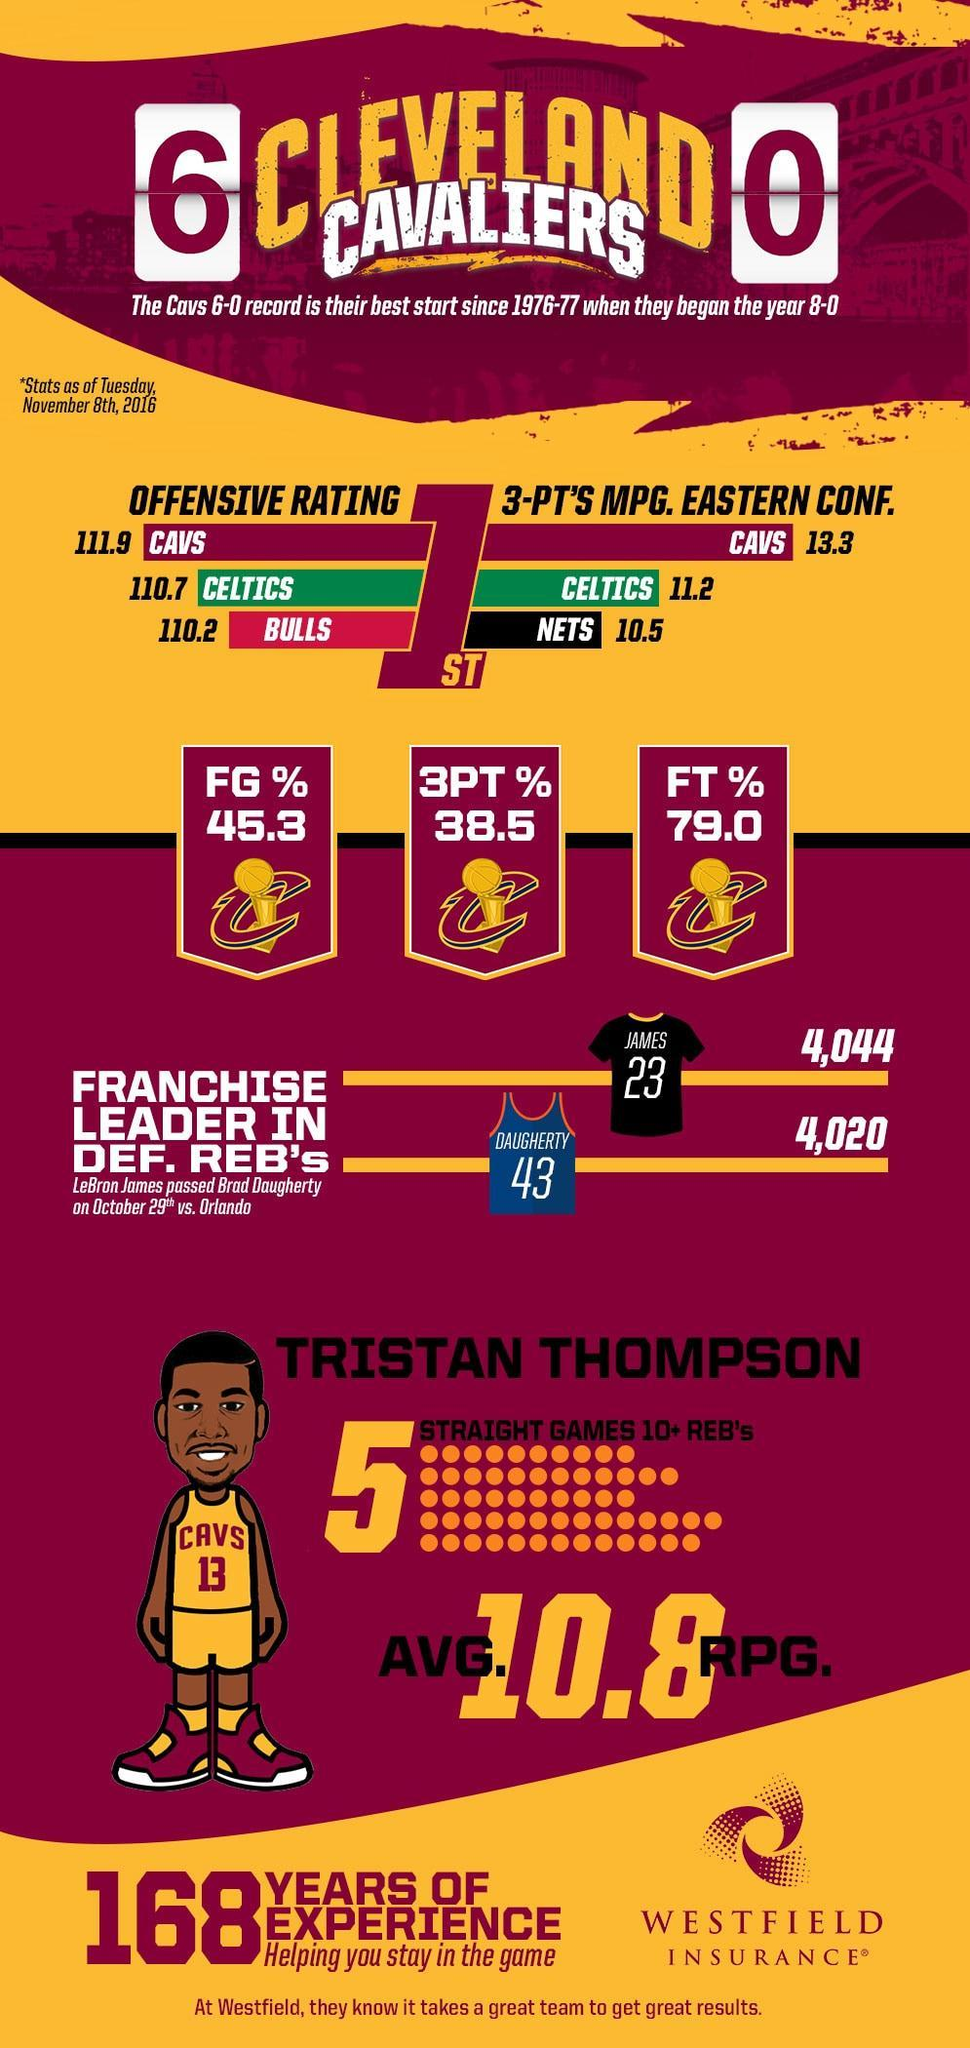Which team did the player Brad Daugherty belong to, Brooklyn Nets, Chicago Bulls, Boston Celtics, or Cleveland Cavaliers?
Answer the question with a short phrase. Cleveland Cavaliers What was the percentage of field goals scored by the Cleveland Cavaliers? 45.3 What is the jersey number of Tristan Thompson? 13 What was the score of Celtics in the 3 points minutes played per game,13.3, 110.7, or 11.2? 11.2 What was the percentage of free throws scored by the Cleveland Cavaliers? 79.0 By how many defensive rebounds did James overtake Daugherty, 43, 24, or 23? 24 Which team did the player LeBron James belong to, Brooklyn Nets, Chicago Bulls, Boston Celtics, or Cleveland Cavaliers? Brooklyn Nets Which team had a lead in defensive rebounds? Nets 